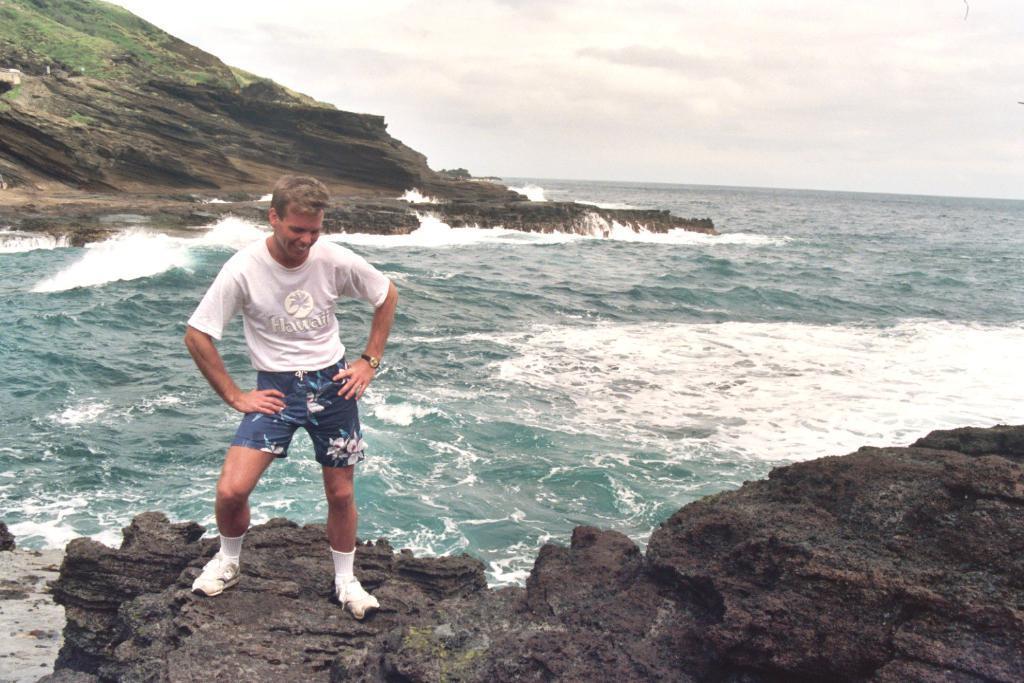How would you summarize this image in a sentence or two? In this picture, we can see a person, the ground, mountain, grass, water and the sky. 